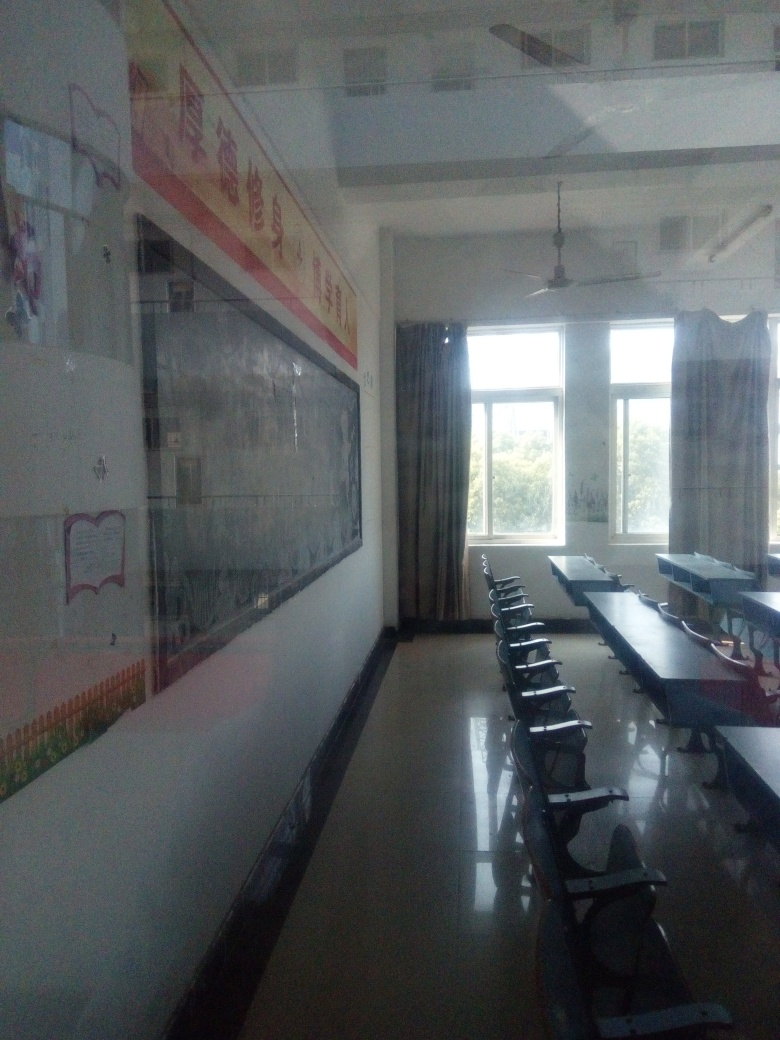What details can you describe about the posters and decorations on the walls? The posters on the walls appear to be educational, with one prominently featuring Chinese characters that suggest a focus on language or cultural education. Other materials, like the world map, support a broad educational purpose for global awareness. 